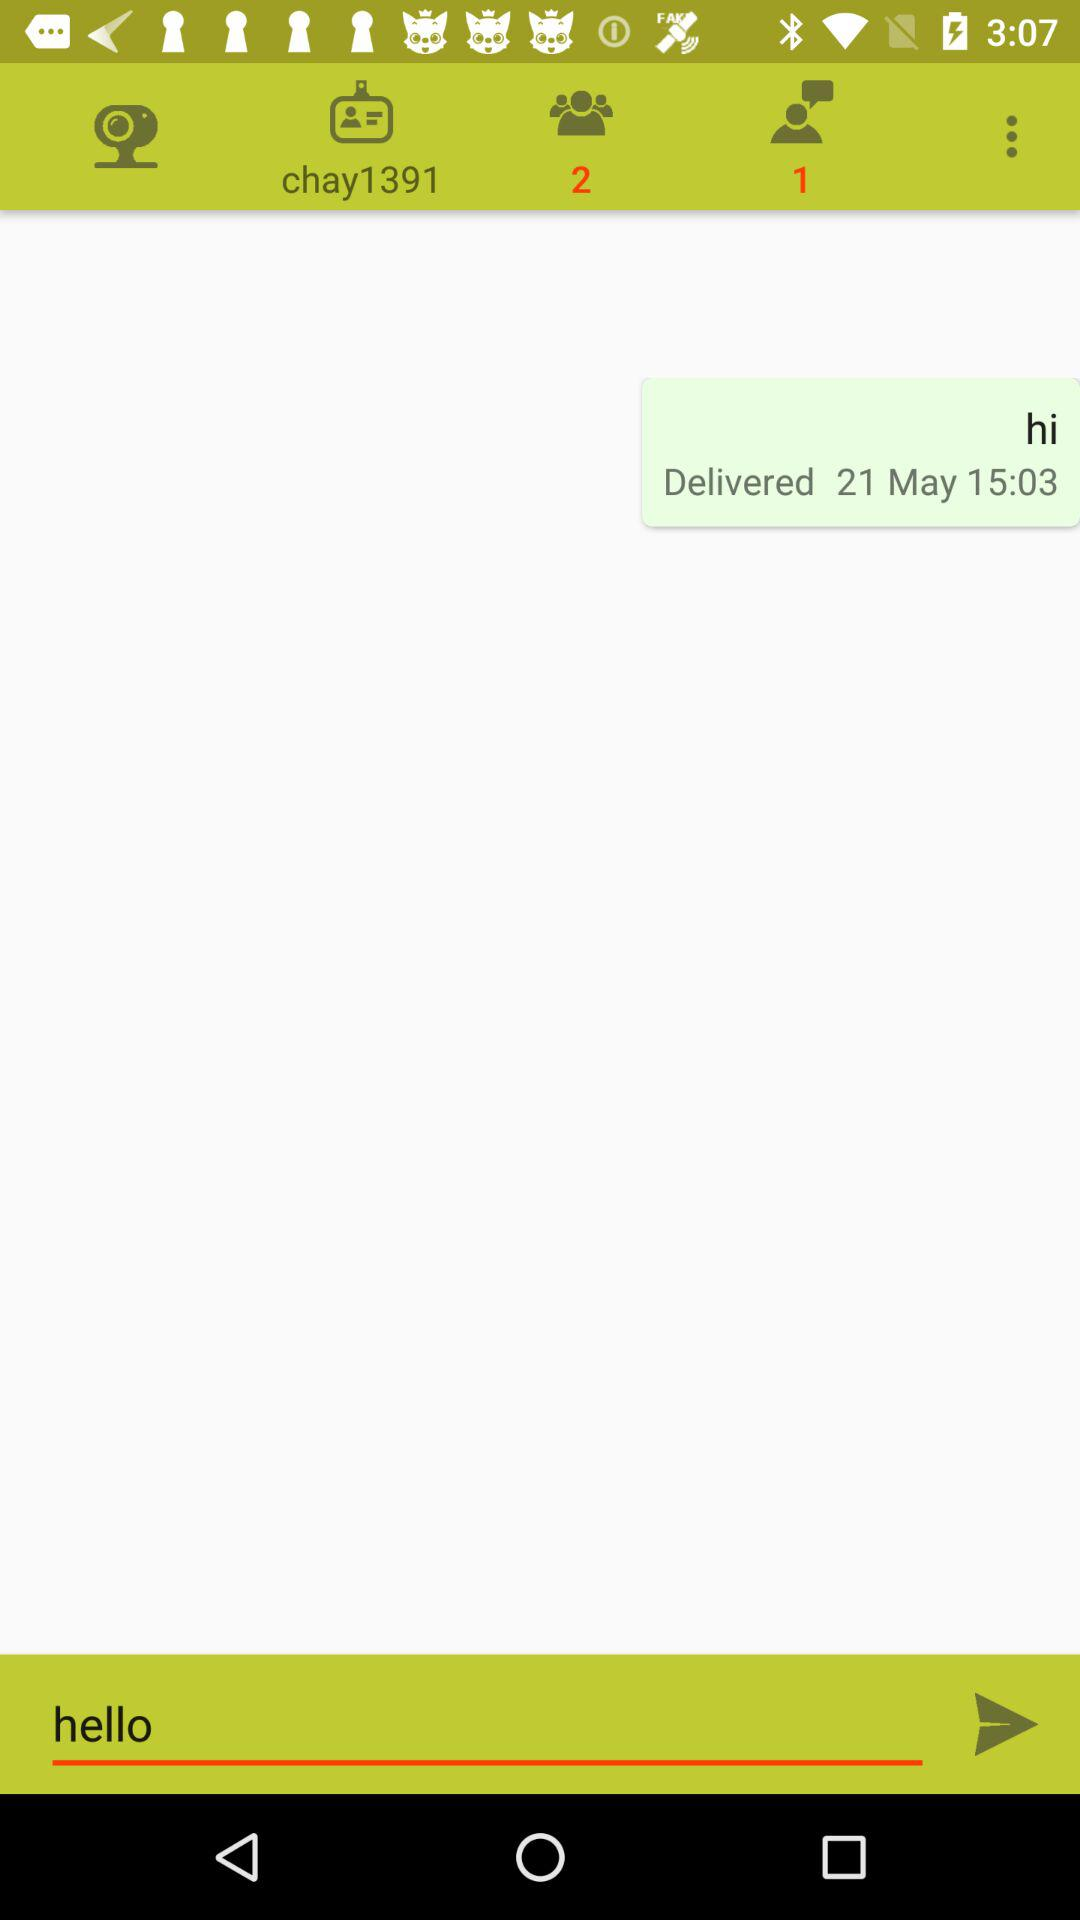Can you tell the time when the screenshot was taken? Yes, the screenshot appears to have been taken at 3:07, as indicated by the time display in the top right corner of the image.  And how long ago was the message sent from the time indicated on the screenshot? The message was delivered on the 21st of May at 15:03, as shown by the timestamp below the message. Since the screenshot was taken at 3:07 on the same day, this suggests that the message was sent approximately 4 minutes before the screenshot was taken. 